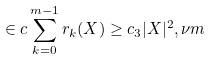<formula> <loc_0><loc_0><loc_500><loc_500>\in c \sum _ { k = 0 } ^ { m - 1 } r _ { k } ( X ) \geq c _ { 3 } | X | ^ { 2 } , \nu m</formula> 